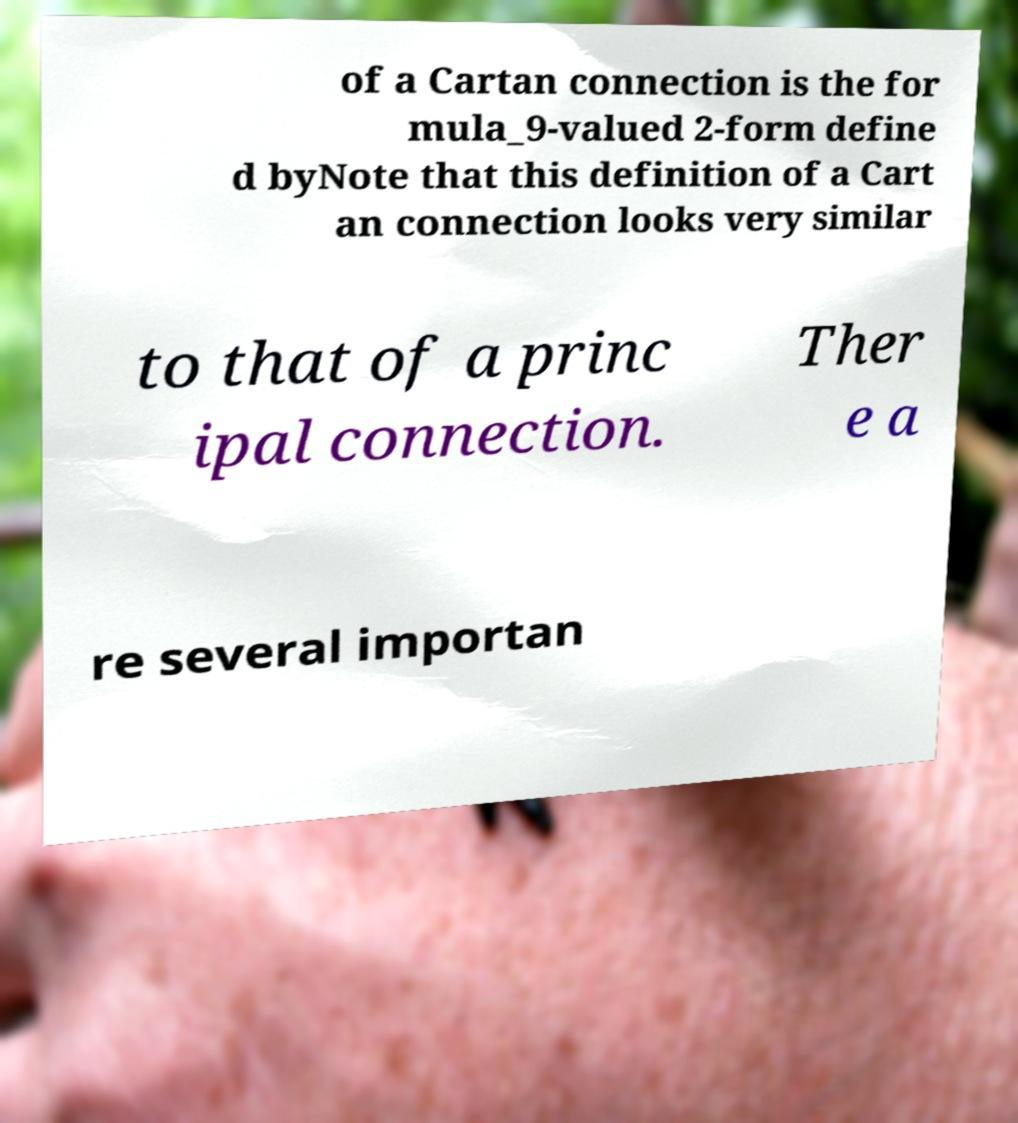Can you read and provide the text displayed in the image?This photo seems to have some interesting text. Can you extract and type it out for me? of a Cartan connection is the for mula_9-valued 2-form define d byNote that this definition of a Cart an connection looks very similar to that of a princ ipal connection. Ther e a re several importan 